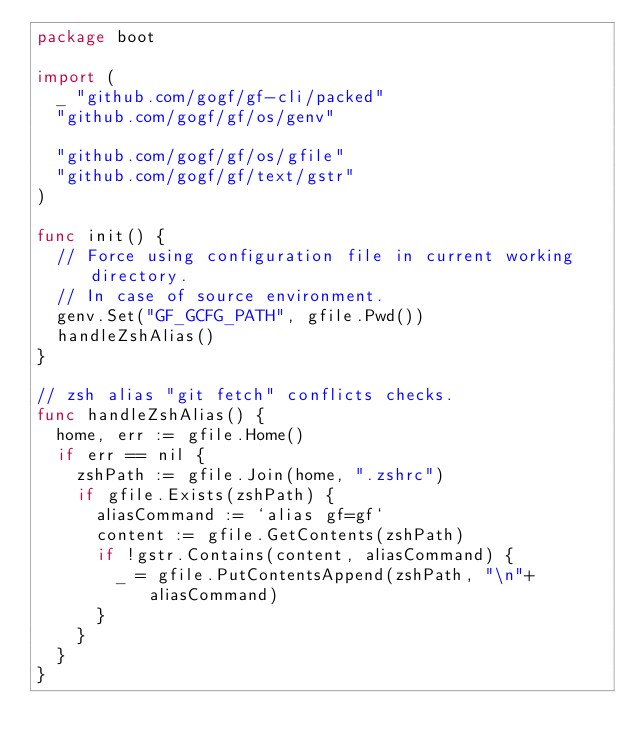Convert code to text. <code><loc_0><loc_0><loc_500><loc_500><_Go_>package boot

import (
	_ "github.com/gogf/gf-cli/packed"
	"github.com/gogf/gf/os/genv"

	"github.com/gogf/gf/os/gfile"
	"github.com/gogf/gf/text/gstr"
)

func init() {
	// Force using configuration file in current working directory.
	// In case of source environment.
	genv.Set("GF_GCFG_PATH", gfile.Pwd())
	handleZshAlias()
}

// zsh alias "git fetch" conflicts checks.
func handleZshAlias() {
	home, err := gfile.Home()
	if err == nil {
		zshPath := gfile.Join(home, ".zshrc")
		if gfile.Exists(zshPath) {
			aliasCommand := `alias gf=gf`
			content := gfile.GetContents(zshPath)
			if !gstr.Contains(content, aliasCommand) {
				_ = gfile.PutContentsAppend(zshPath, "\n"+aliasCommand)
			}
		}
	}
}
</code> 